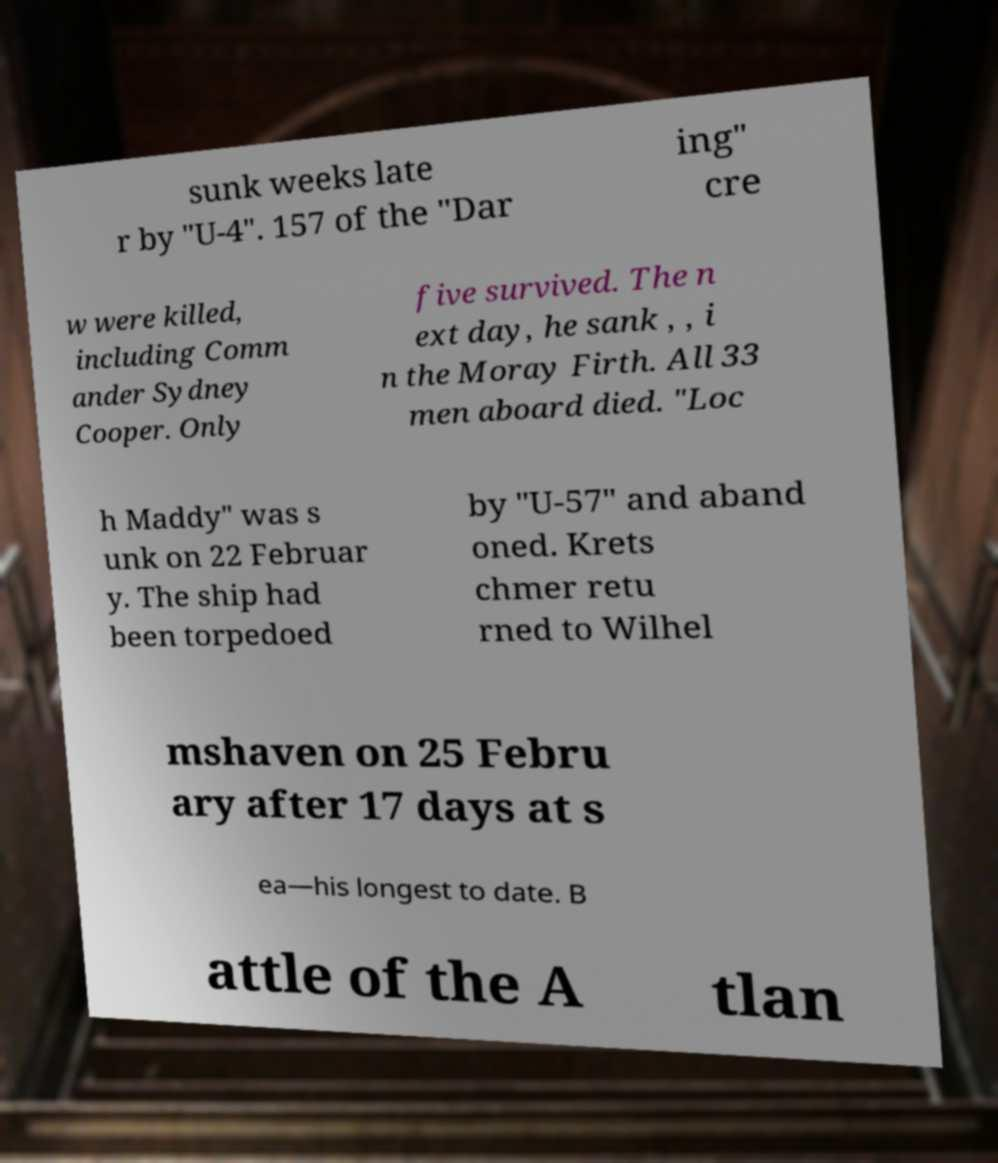Please identify and transcribe the text found in this image. sunk weeks late r by "U-4". 157 of the "Dar ing" cre w were killed, including Comm ander Sydney Cooper. Only five survived. The n ext day, he sank , , i n the Moray Firth. All 33 men aboard died. "Loc h Maddy" was s unk on 22 Februar y. The ship had been torpedoed by "U-57" and aband oned. Krets chmer retu rned to Wilhel mshaven on 25 Febru ary after 17 days at s ea—his longest to date. B attle of the A tlan 